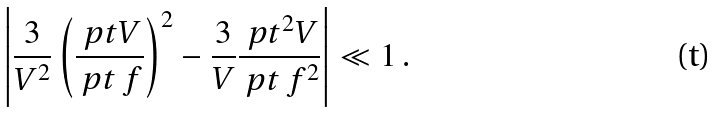<formula> <loc_0><loc_0><loc_500><loc_500>\left | \frac { 3 } { V ^ { 2 } } \left ( \frac { \ p t V } { \ p t \ f } \right ) ^ { 2 } - \frac { 3 } { V } \frac { \ p t ^ { 2 } V } { \ p t \ f ^ { 2 } } \right | \ll 1 \, .</formula> 